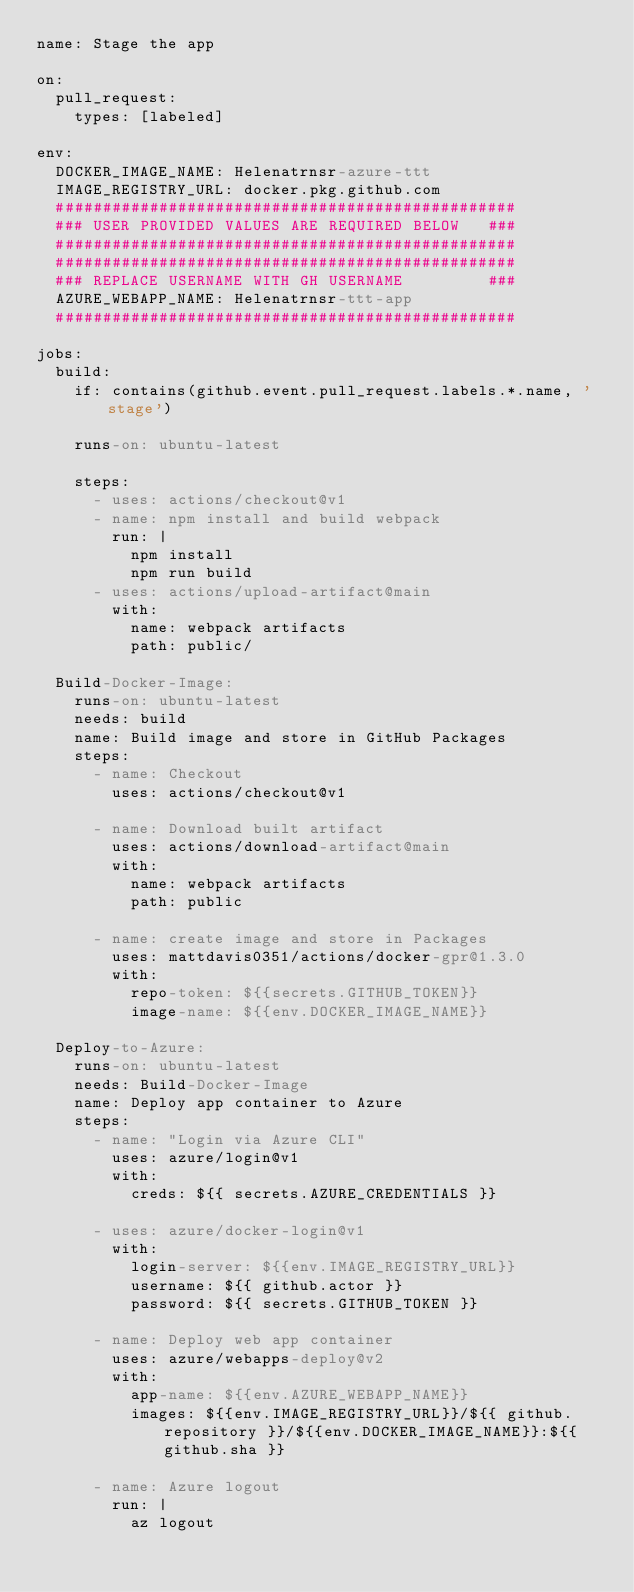<code> <loc_0><loc_0><loc_500><loc_500><_YAML_>name: Stage the app

on: 
  pull_request:
    types: [labeled]

env:
  DOCKER_IMAGE_NAME: Helenatrnsr-azure-ttt
  IMAGE_REGISTRY_URL: docker.pkg.github.com
  #################################################
  ### USER PROVIDED VALUES ARE REQUIRED BELOW   ###
  #################################################
  #################################################
  ### REPLACE USERNAME WITH GH USERNAME         ###
  AZURE_WEBAPP_NAME: Helenatrnsr-ttt-app
  #################################################

jobs:
  build:
    if: contains(github.event.pull_request.labels.*.name, 'stage')

    runs-on: ubuntu-latest

    steps:
      - uses: actions/checkout@v1
      - name: npm install and build webpack
        run: |
          npm install
          npm run build
      - uses: actions/upload-artifact@main
        with:
          name: webpack artifacts
          path: public/

  Build-Docker-Image:
    runs-on: ubuntu-latest
    needs: build
    name: Build image and store in GitHub Packages
    steps:
      - name: Checkout
        uses: actions/checkout@v1

      - name: Download built artifact
        uses: actions/download-artifact@main
        with:
          name: webpack artifacts
          path: public

      - name: create image and store in Packages
        uses: mattdavis0351/actions/docker-gpr@1.3.0
        with:
          repo-token: ${{secrets.GITHUB_TOKEN}}
          image-name: ${{env.DOCKER_IMAGE_NAME}}

  Deploy-to-Azure:
    runs-on: ubuntu-latest
    needs: Build-Docker-Image
    name: Deploy app container to Azure
    steps:
      - name: "Login via Azure CLI"
        uses: azure/login@v1
        with:
          creds: ${{ secrets.AZURE_CREDENTIALS }}

      - uses: azure/docker-login@v1
        with:
          login-server: ${{env.IMAGE_REGISTRY_URL}}
          username: ${{ github.actor }}
          password: ${{ secrets.GITHUB_TOKEN }}

      - name: Deploy web app container
        uses: azure/webapps-deploy@v2
        with:
          app-name: ${{env.AZURE_WEBAPP_NAME}}
          images: ${{env.IMAGE_REGISTRY_URL}}/${{ github.repository }}/${{env.DOCKER_IMAGE_NAME}}:${{ github.sha }}

      - name: Azure logout
        run: |
          az logout
</code> 